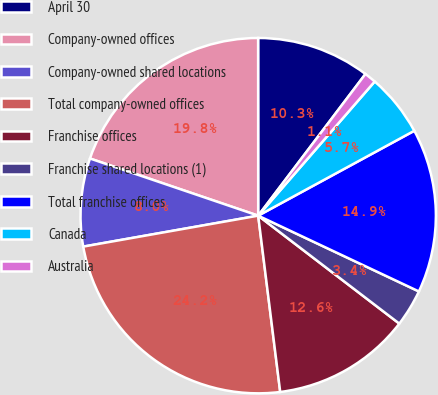<chart> <loc_0><loc_0><loc_500><loc_500><pie_chart><fcel>April 30<fcel>Company-owned offices<fcel>Company-owned shared locations<fcel>Total company-owned offices<fcel>Franchise offices<fcel>Franchise shared locations (1)<fcel>Total franchise offices<fcel>Canada<fcel>Australia<nl><fcel>10.32%<fcel>19.78%<fcel>8.0%<fcel>24.19%<fcel>12.63%<fcel>3.38%<fcel>14.94%<fcel>5.69%<fcel>1.07%<nl></chart> 